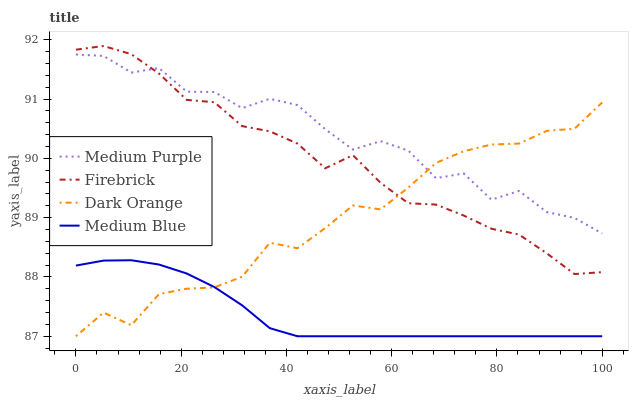Does Medium Blue have the minimum area under the curve?
Answer yes or no. Yes. Does Medium Purple have the maximum area under the curve?
Answer yes or no. Yes. Does Dark Orange have the minimum area under the curve?
Answer yes or no. No. Does Dark Orange have the maximum area under the curve?
Answer yes or no. No. Is Medium Blue the smoothest?
Answer yes or no. Yes. Is Medium Purple the roughest?
Answer yes or no. Yes. Is Dark Orange the smoothest?
Answer yes or no. No. Is Dark Orange the roughest?
Answer yes or no. No. Does Dark Orange have the lowest value?
Answer yes or no. Yes. Does Firebrick have the lowest value?
Answer yes or no. No. Does Firebrick have the highest value?
Answer yes or no. Yes. Does Dark Orange have the highest value?
Answer yes or no. No. Is Medium Blue less than Firebrick?
Answer yes or no. Yes. Is Medium Purple greater than Medium Blue?
Answer yes or no. Yes. Does Dark Orange intersect Medium Purple?
Answer yes or no. Yes. Is Dark Orange less than Medium Purple?
Answer yes or no. No. Is Dark Orange greater than Medium Purple?
Answer yes or no. No. Does Medium Blue intersect Firebrick?
Answer yes or no. No. 